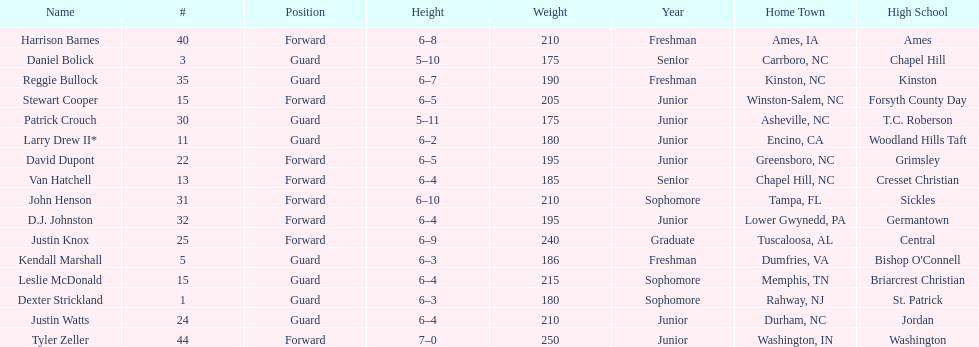How many players have a hometown in north carolina (nc)? 7. Can you parse all the data within this table? {'header': ['Name', '#', 'Position', 'Height', 'Weight', 'Year', 'Home Town', 'High School'], 'rows': [['Harrison Barnes', '40', 'Forward', '6–8', '210', 'Freshman', 'Ames, IA', 'Ames'], ['Daniel Bolick', '3', 'Guard', '5–10', '175', 'Senior', 'Carrboro, NC', 'Chapel Hill'], ['Reggie Bullock', '35', 'Guard', '6–7', '190', 'Freshman', 'Kinston, NC', 'Kinston'], ['Stewart Cooper', '15', 'Forward', '6–5', '205', 'Junior', 'Winston-Salem, NC', 'Forsyth County Day'], ['Patrick Crouch', '30', 'Guard', '5–11', '175', 'Junior', 'Asheville, NC', 'T.C. Roberson'], ['Larry Drew II*', '11', 'Guard', '6–2', '180', 'Junior', 'Encino, CA', 'Woodland Hills Taft'], ['David Dupont', '22', 'Forward', '6–5', '195', 'Junior', 'Greensboro, NC', 'Grimsley'], ['Van Hatchell', '13', 'Forward', '6–4', '185', 'Senior', 'Chapel Hill, NC', 'Cresset Christian'], ['John Henson', '31', 'Forward', '6–10', '210', 'Sophomore', 'Tampa, FL', 'Sickles'], ['D.J. Johnston', '32', 'Forward', '6–4', '195', 'Junior', 'Lower Gwynedd, PA', 'Germantown'], ['Justin Knox', '25', 'Forward', '6–9', '240', 'Graduate', 'Tuscaloosa, AL', 'Central'], ['Kendall Marshall', '5', 'Guard', '6–3', '186', 'Freshman', 'Dumfries, VA', "Bishop O'Connell"], ['Leslie McDonald', '15', 'Guard', '6–4', '215', 'Sophomore', 'Memphis, TN', 'Briarcrest Christian'], ['Dexter Strickland', '1', 'Guard', '6–3', '180', 'Sophomore', 'Rahway, NJ', 'St. Patrick'], ['Justin Watts', '24', 'Guard', '6–4', '210', 'Junior', 'Durham, NC', 'Jordan'], ['Tyler Zeller', '44', 'Forward', '7–0', '250', 'Junior', 'Washington, IN', 'Washington']]} 